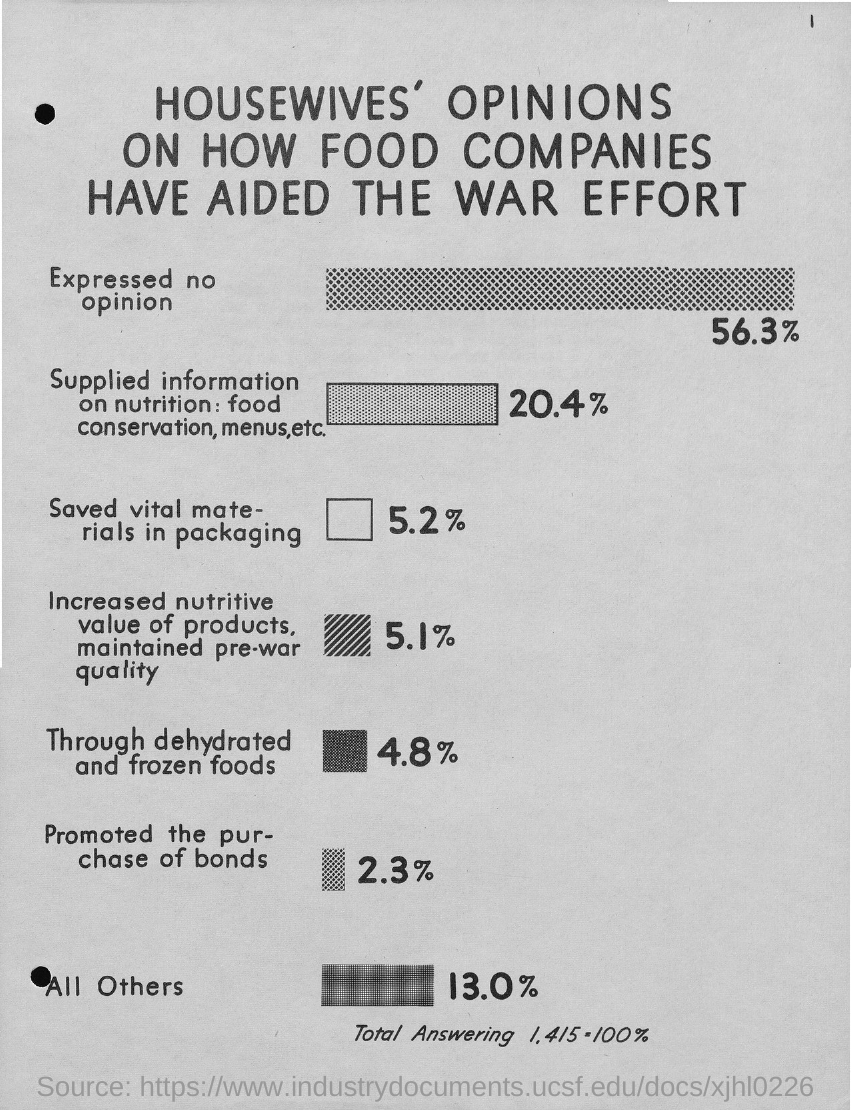What is the percentage of housewives expressed no opinion?
Ensure brevity in your answer.  56.3%. 